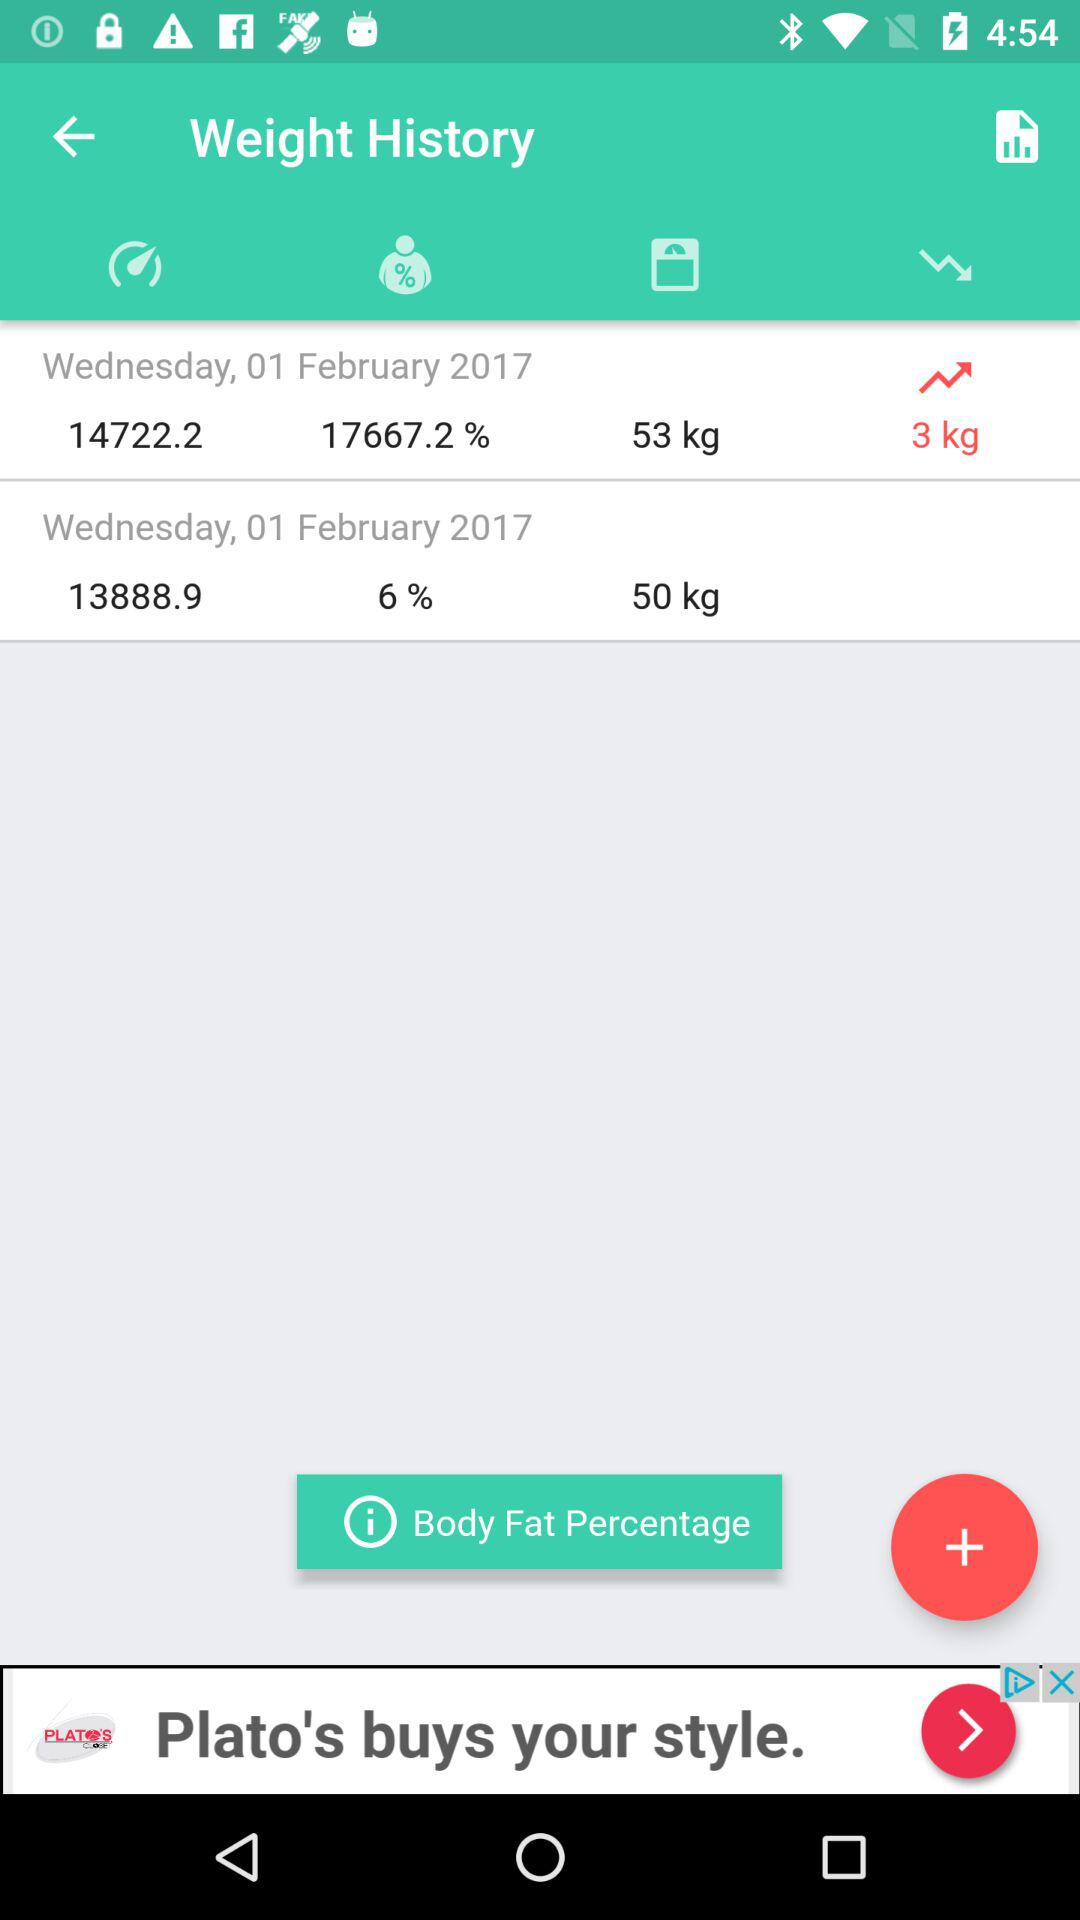How much weight is gained? Weight gained is 3 kg. 